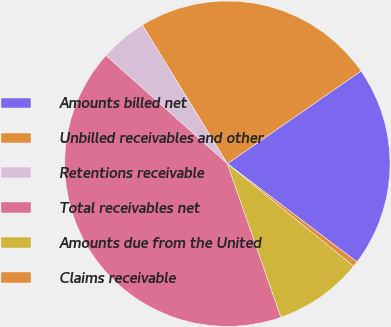Convert chart. <chart><loc_0><loc_0><loc_500><loc_500><pie_chart><fcel>Amounts billed net<fcel>Unbilled receivables and other<fcel>Retentions receivable<fcel>Total receivables net<fcel>Amounts due from the United<fcel>Claims receivable<nl><fcel>19.96%<fcel>24.1%<fcel>4.67%<fcel>41.92%<fcel>8.81%<fcel>0.53%<nl></chart> 